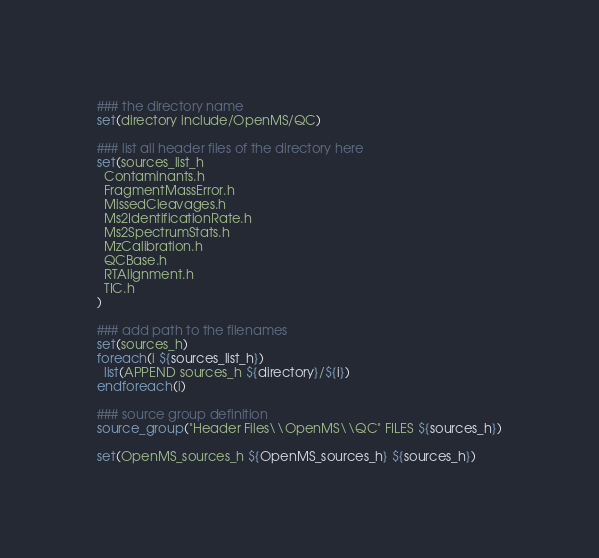<code> <loc_0><loc_0><loc_500><loc_500><_CMake_>### the directory name
set(directory include/OpenMS/QC)

### list all header files of the directory here
set(sources_list_h
  Contaminants.h
  FragmentMassError.h
  MissedCleavages.h
  Ms2IdentificationRate.h
  Ms2SpectrumStats.h
  MzCalibration.h
  QCBase.h
  RTAlignment.h
  TIC.h
)

### add path to the filenames
set(sources_h)
foreach(i ${sources_list_h})
  list(APPEND sources_h ${directory}/${i})
endforeach(i)

### source group definition
source_group("Header Files\\OpenMS\\QC" FILES ${sources_h})

set(OpenMS_sources_h ${OpenMS_sources_h} ${sources_h})
</code> 